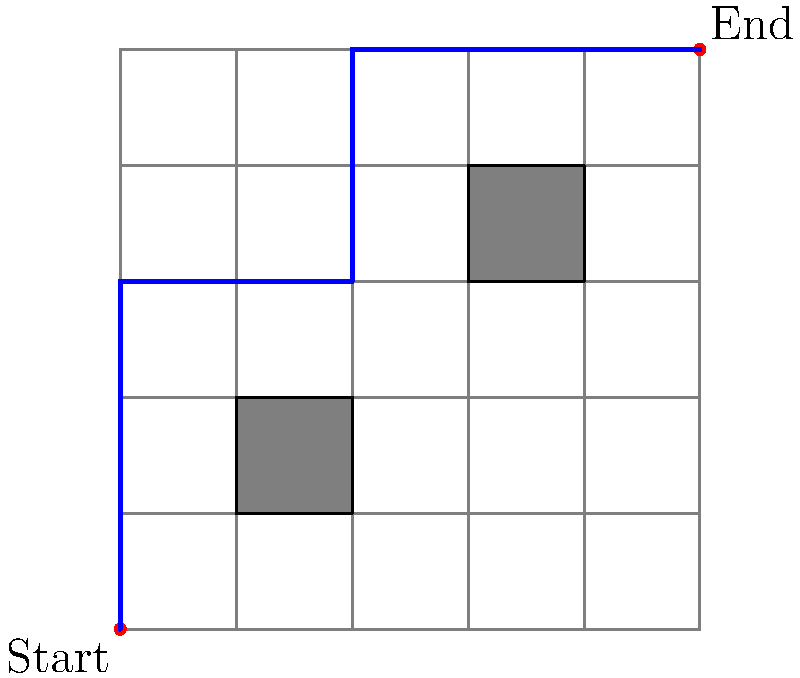As a Swedish telco executive, you're tasked with finding the most efficient cable routing path through a city grid from the start point (0,0) to the end point (5,5). The grid is 5x5, and there are two building obstacles that cannot be crossed. What is the length of the shortest path, assuming each grid unit represents 1 km? To find the shortest path, we need to follow these steps:

1. Analyze the grid: The grid is 5x5, with obstacles at (1,1) to (2,2) and (3,3) to (4,4).

2. Identify possible paths: The shortest path will avoid obstacles and use as few turns as possible.

3. Calculate the shortest path:
   - Start at (0,0)
   - Move up to (0,3) to avoid the first obstacle: 3 units
   - Move right to (2,3): 2 units
   - Move up to (2,5): 2 units
   - Move right to (5,5): 3 units

4. Sum up the total distance:
   $$ \text{Total distance} = 3 + 2 + 2 + 3 = 10 \text{ units} $$

5. Convert to kilometers:
   Since each unit represents 1 km, the total distance is 10 km.

This path is optimal because:
- It uses the minimum number of turns (3 turns)
- It avoids both obstacles efficiently
- Any other path would either cross obstacles or be longer
Answer: 10 km 